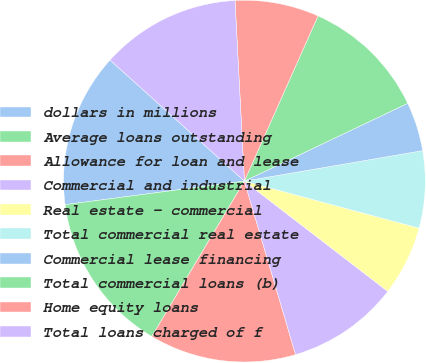Convert chart to OTSL. <chart><loc_0><loc_0><loc_500><loc_500><pie_chart><fcel>dollars in millions<fcel>Average loans outstanding<fcel>Allowance for loan and lease<fcel>Commercial and industrial<fcel>Real estate - commercial<fcel>Total commercial real estate<fcel>Commercial lease financing<fcel>Total commercial loans (b)<fcel>Home equity loans<fcel>Total loans charged of f<nl><fcel>13.75%<fcel>14.37%<fcel>13.12%<fcel>10.0%<fcel>6.25%<fcel>6.88%<fcel>4.38%<fcel>11.25%<fcel>7.5%<fcel>12.5%<nl></chart> 